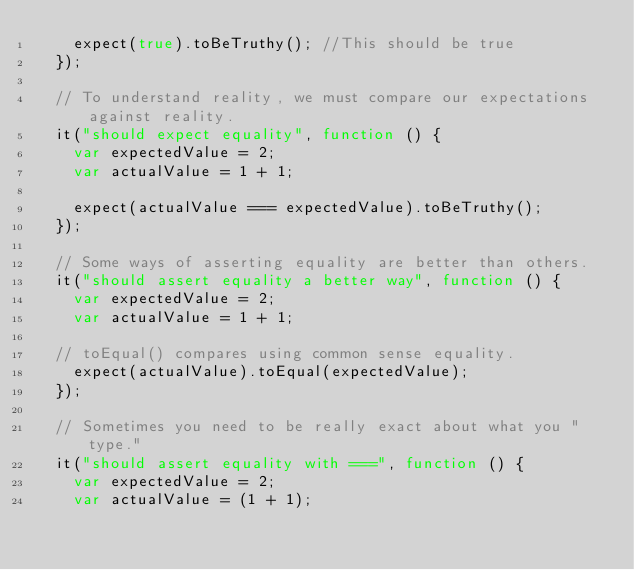Convert code to text. <code><loc_0><loc_0><loc_500><loc_500><_JavaScript_>    expect(true).toBeTruthy(); //This should be true
  });

  // To understand reality, we must compare our expectations against reality.
  it("should expect equality", function () {
    var expectedValue = 2;
    var actualValue = 1 + 1;

    expect(actualValue === expectedValue).toBeTruthy();
  });

  // Some ways of asserting equality are better than others.
  it("should assert equality a better way", function () {
    var expectedValue = 2;
    var actualValue = 1 + 1;

  // toEqual() compares using common sense equality.
    expect(actualValue).toEqual(expectedValue);
  });

  // Sometimes you need to be really exact about what you "type."
  it("should assert equality with ===", function () {
    var expectedValue = 2;
    var actualValue = (1 + 1);
</code> 